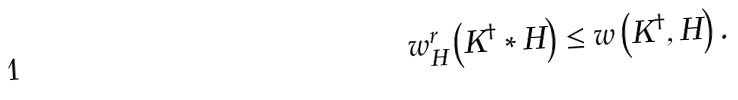<formula> <loc_0><loc_0><loc_500><loc_500>w _ { H } ^ { r } \left ( K ^ { \dagger } \ast H \right ) \leq w \left ( K ^ { \dagger } , H \right ) .</formula> 